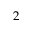<formula> <loc_0><loc_0><loc_500><loc_500>2</formula> 